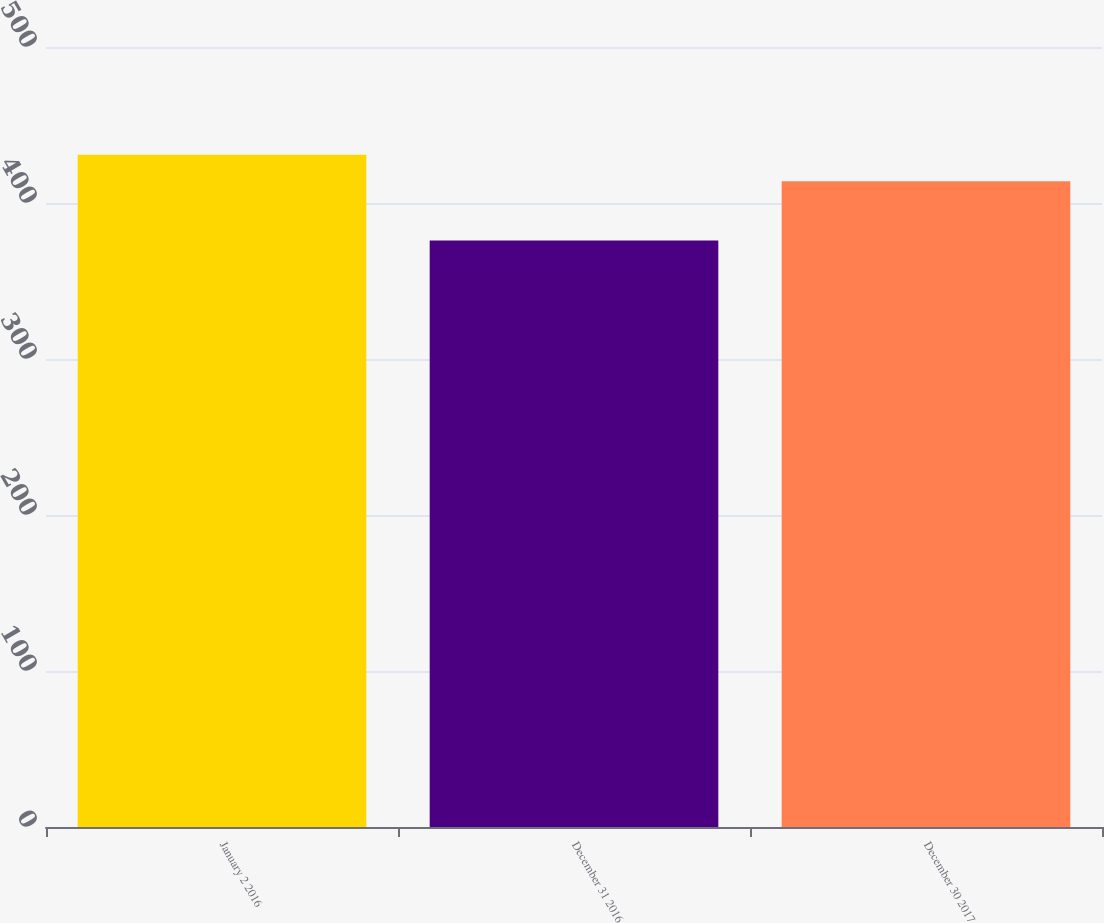Convert chart to OTSL. <chart><loc_0><loc_0><loc_500><loc_500><bar_chart><fcel>January 2 2016<fcel>December 31 2016<fcel>December 30 2017<nl><fcel>431<fcel>376<fcel>414<nl></chart> 